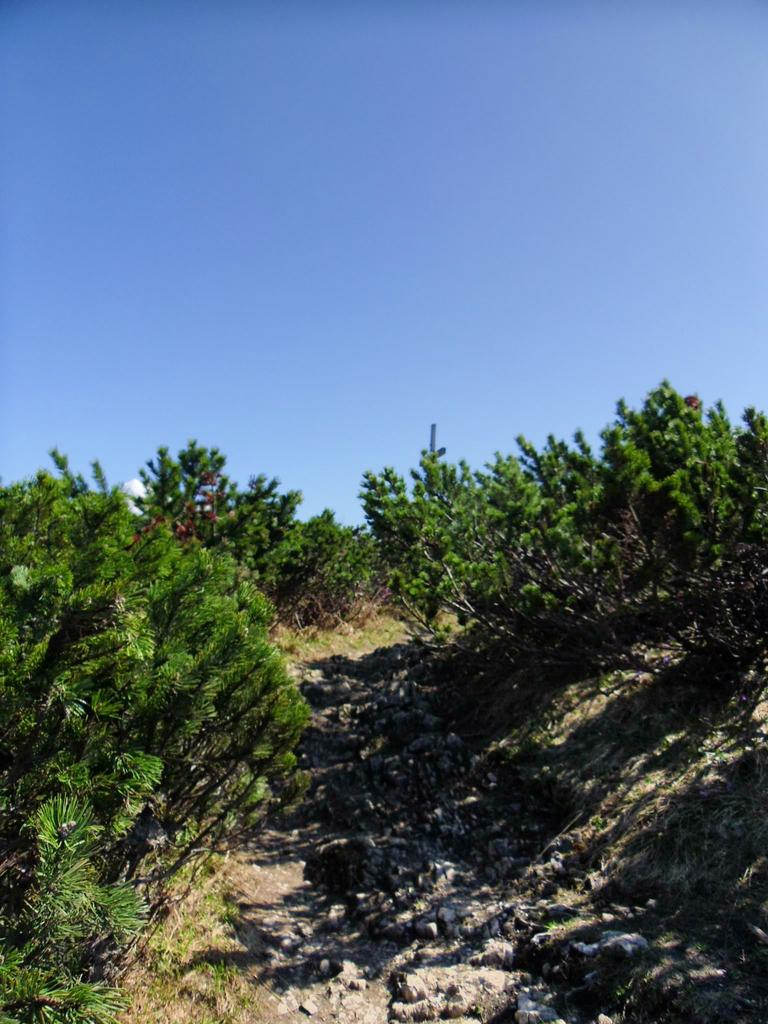What type of living organisms can be seen in the image? Plants can be seen in the image. Where are the plants located in relation to other objects? The plants are around a rock surface. What type of class is being held near the plants in the image? There is no class or indication of any educational activity present in the image. 